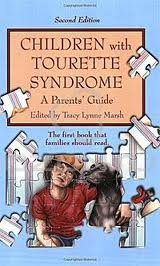Is this a crafts or hobbies related book? No, this book does not cover crafts or hobbies. It is specifically dedicated to providing advice and understanding about Tourette Syndrome. 